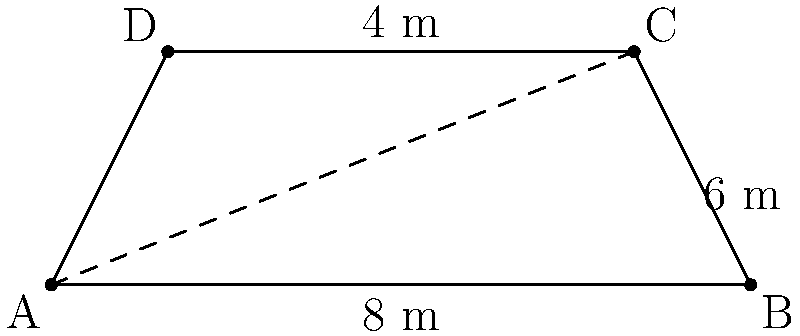For your next viral social media campaign, you need a trapezoid-shaped banner. The banner's bottom edge measures 8 meters, the top edge is 4 meters, and the height is 4 meters. What is the area of this eye-catching banner that will boost your influencer status? To find the area of a trapezoid, we use the formula:

$$A = \frac{1}{2}(b_1 + b_2)h$$

Where:
$A$ = Area
$b_1$ = Length of one parallel side
$b_2$ = Length of the other parallel side
$h$ = Height of the trapezoid

Given:
$b_1 = 8$ meters (bottom edge)
$b_2 = 4$ meters (top edge)
$h = 4$ meters (height)

Let's substitute these values into the formula:

$$A = \frac{1}{2}(8 + 4) \times 4$$

$$A = \frac{1}{2}(12) \times 4$$

$$A = 6 \times 4$$

$$A = 24$$

Therefore, the area of the trapezoid-shaped banner is 24 square meters.
Answer: 24 m² 